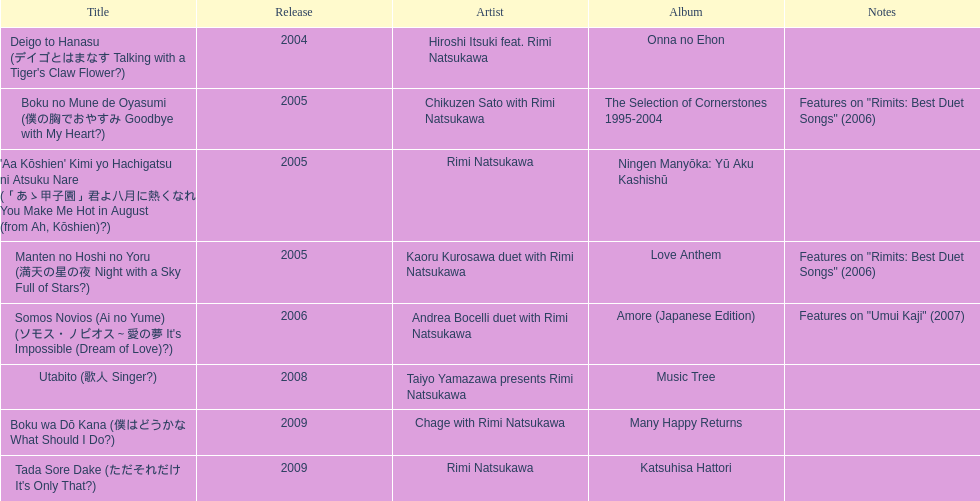How many titles are attributed to just one artist? 2. 